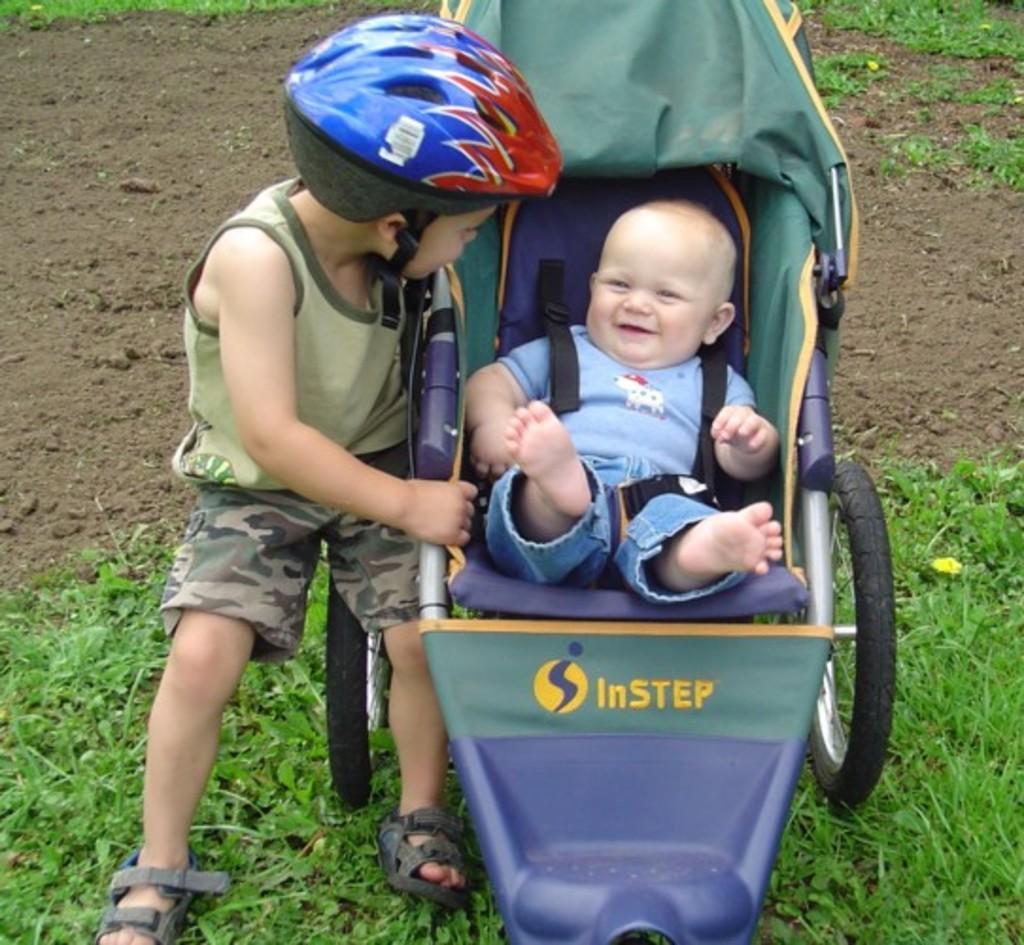Can you describe this image briefly? In this image we can see kid wearing helmet, short sitting on the wheel chair in which there is a kid wearing blue color dress and in the background we can see grass. 